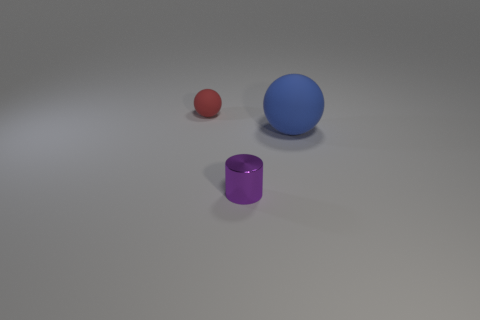Is there a source of light in the image, and if so, what direction is it coming from? Although no direct light source is visible in the image, the shadows cast by the objects indicate there is a light source above and to the left, illuminating the scene and creating soft shadows on the ground to the right of each object. 